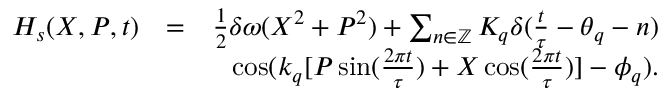Convert formula to latex. <formula><loc_0><loc_0><loc_500><loc_500>\begin{array} { r l r } { H _ { s } ( X , P , t ) } & { = } & { \frac { 1 } { 2 } \delta \omega ( X ^ { 2 } + P ^ { 2 } ) + \sum _ { n \in \mathbb { Z } } K _ { q } \delta ( \frac { t } { \tau } - \theta _ { q } - n ) } \\ & { \cos ( k _ { q } [ P \sin ( \frac { 2 \pi t } { \tau } ) + X \cos ( \frac { 2 \pi t } { \tau } ) ] - \phi _ { q } ) . } \\ & \end{array}</formula> 